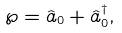<formula> <loc_0><loc_0><loc_500><loc_500>\wp = \hat { a } _ { 0 } + \hat { a } _ { 0 } ^ { \dagger } ,</formula> 